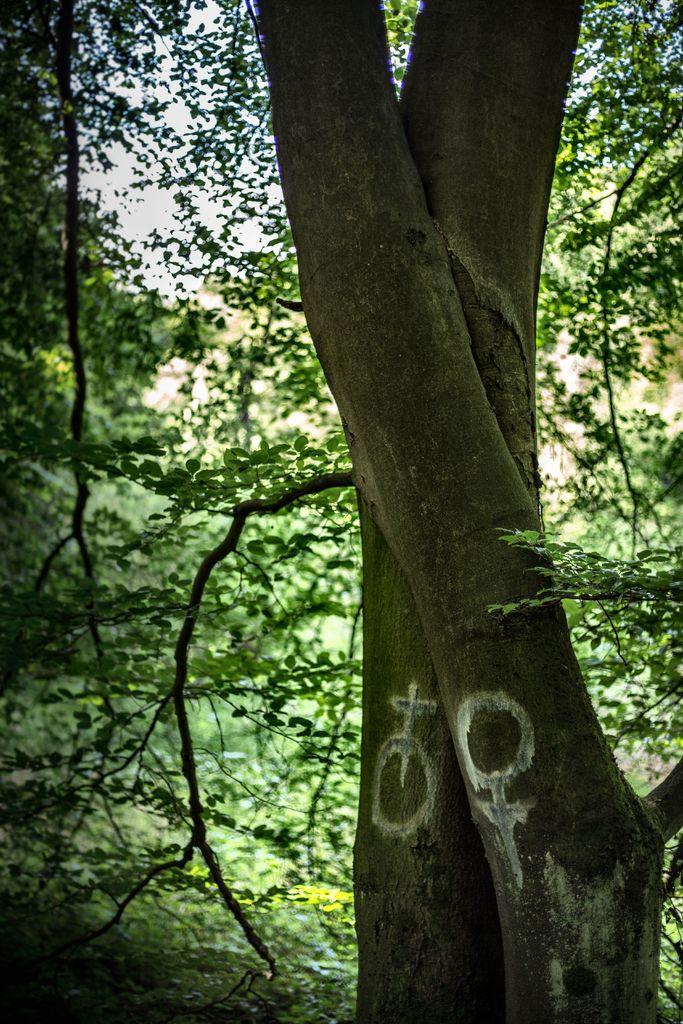In one or two sentences, can you explain what this image depicts? This is the picture of a tree trunk on which there is a white paint and behind there are some plants and trees. 